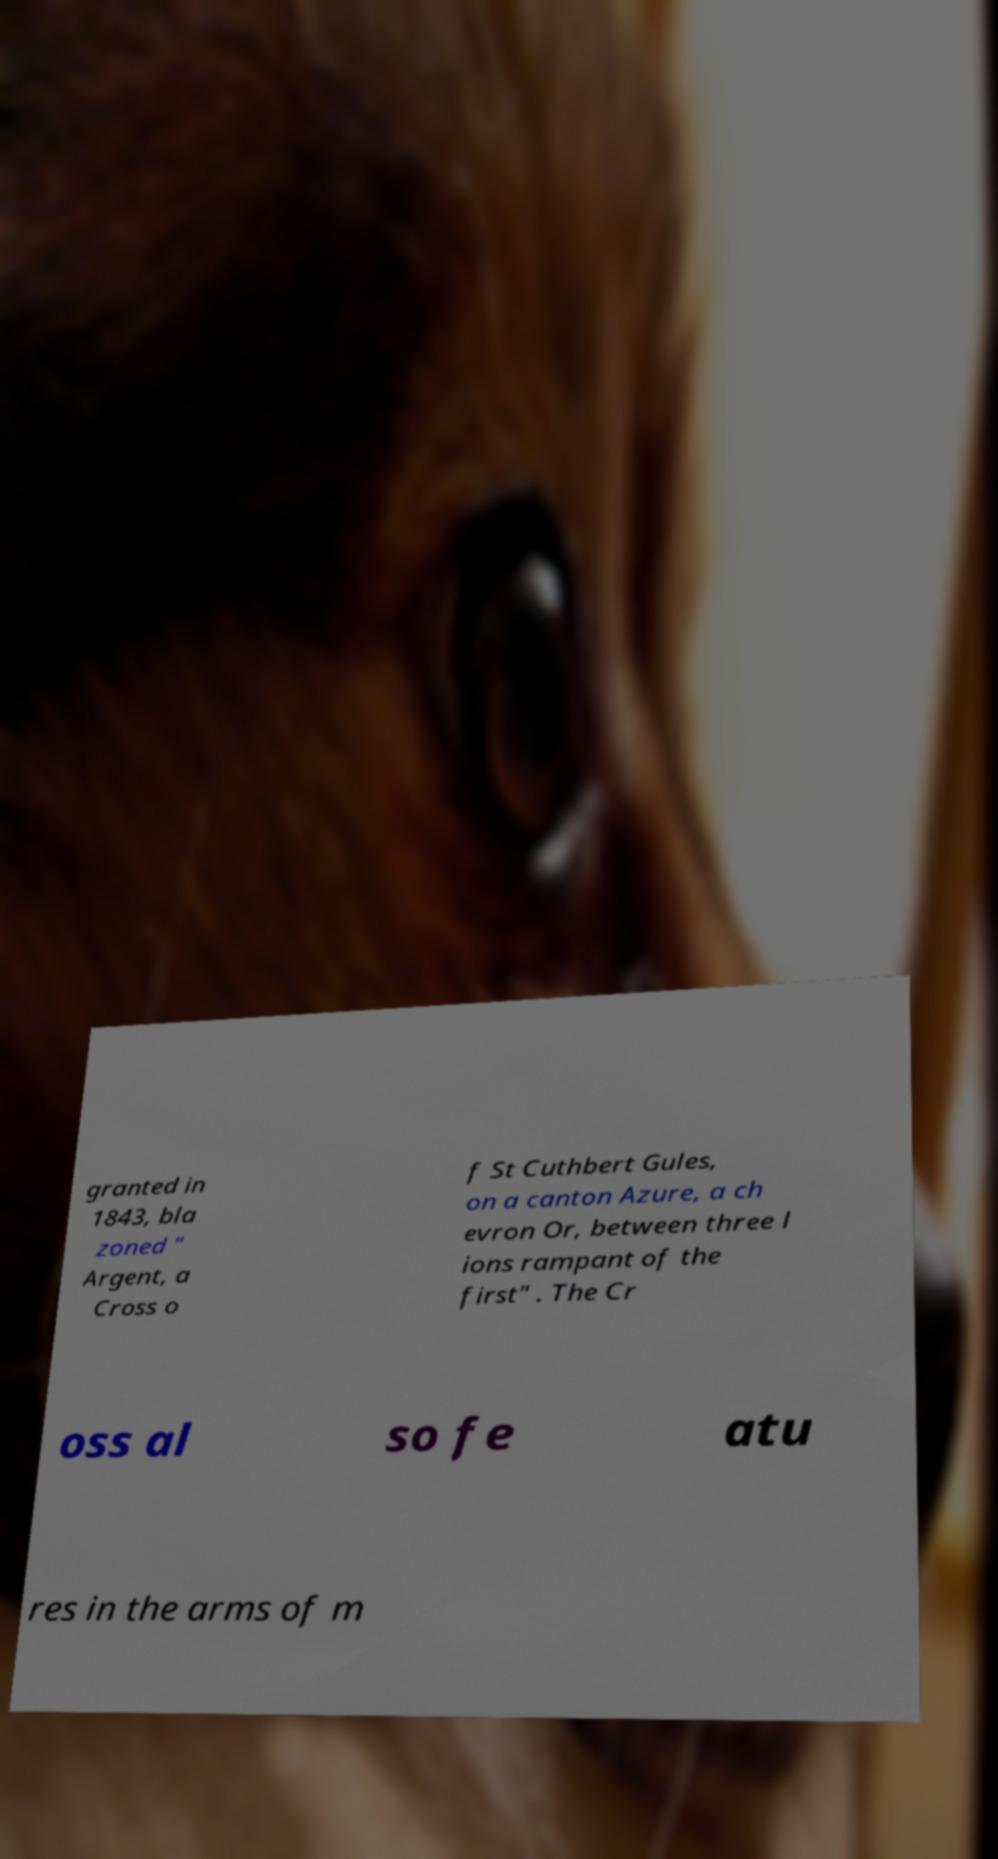Can you read and provide the text displayed in the image?This photo seems to have some interesting text. Can you extract and type it out for me? granted in 1843, bla zoned " Argent, a Cross o f St Cuthbert Gules, on a canton Azure, a ch evron Or, between three l ions rampant of the first" . The Cr oss al so fe atu res in the arms of m 